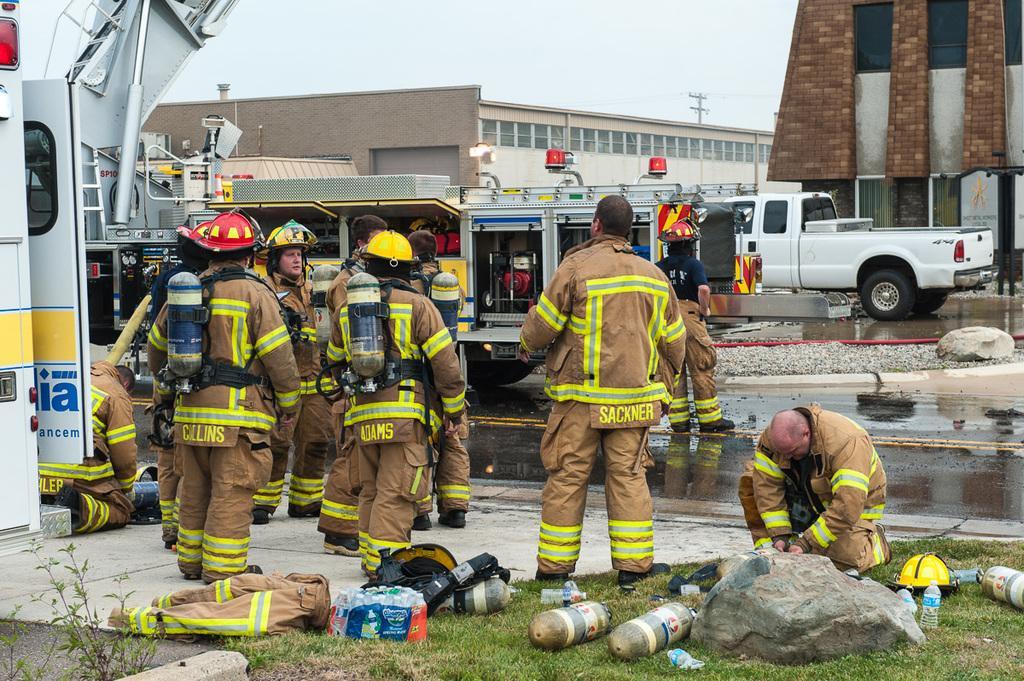How would you summarize this image in a sentence or two? In this image in front there is grass on the surface and there are few objects on the surface of the grass. We can see a few people are standing on the road. In front of them there are vehicles. In the background there are buildings and sky. 